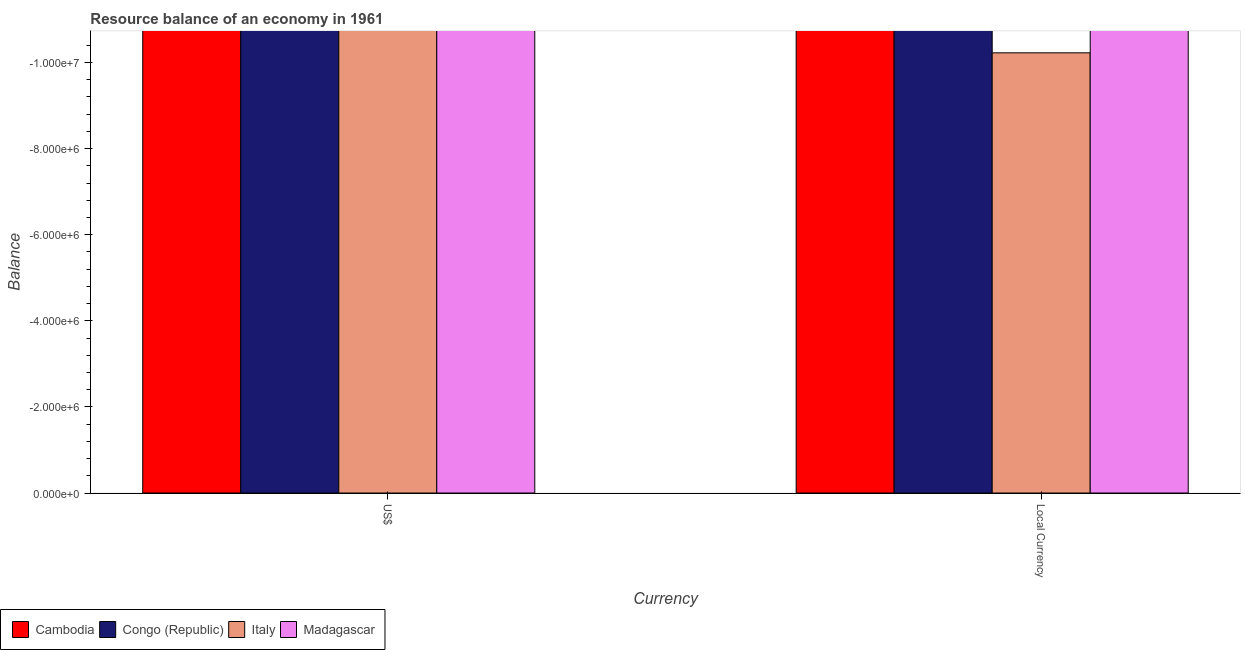How many different coloured bars are there?
Your answer should be compact. 0. Are the number of bars on each tick of the X-axis equal?
Your response must be concise. Yes. What is the label of the 2nd group of bars from the left?
Your answer should be very brief. Local Currency. Across all countries, what is the minimum resource balance in constant us$?
Give a very brief answer. 0. What is the average resource balance in us$ per country?
Ensure brevity in your answer.  0. How many countries are there in the graph?
Your answer should be compact. 4. What is the difference between two consecutive major ticks on the Y-axis?
Your response must be concise. 2.00e+06. Are the values on the major ticks of Y-axis written in scientific E-notation?
Your response must be concise. Yes. Does the graph contain grids?
Offer a terse response. No. What is the title of the graph?
Make the answer very short. Resource balance of an economy in 1961. What is the label or title of the X-axis?
Keep it short and to the point. Currency. What is the label or title of the Y-axis?
Provide a succinct answer. Balance. What is the Balance of Cambodia in US$?
Your answer should be compact. 0. What is the Balance of Congo (Republic) in US$?
Ensure brevity in your answer.  0. What is the Balance of Cambodia in Local Currency?
Keep it short and to the point. 0. What is the total Balance of Madagascar in the graph?
Give a very brief answer. 0. What is the average Balance of Cambodia per Currency?
Make the answer very short. 0. What is the average Balance of Congo (Republic) per Currency?
Make the answer very short. 0. 